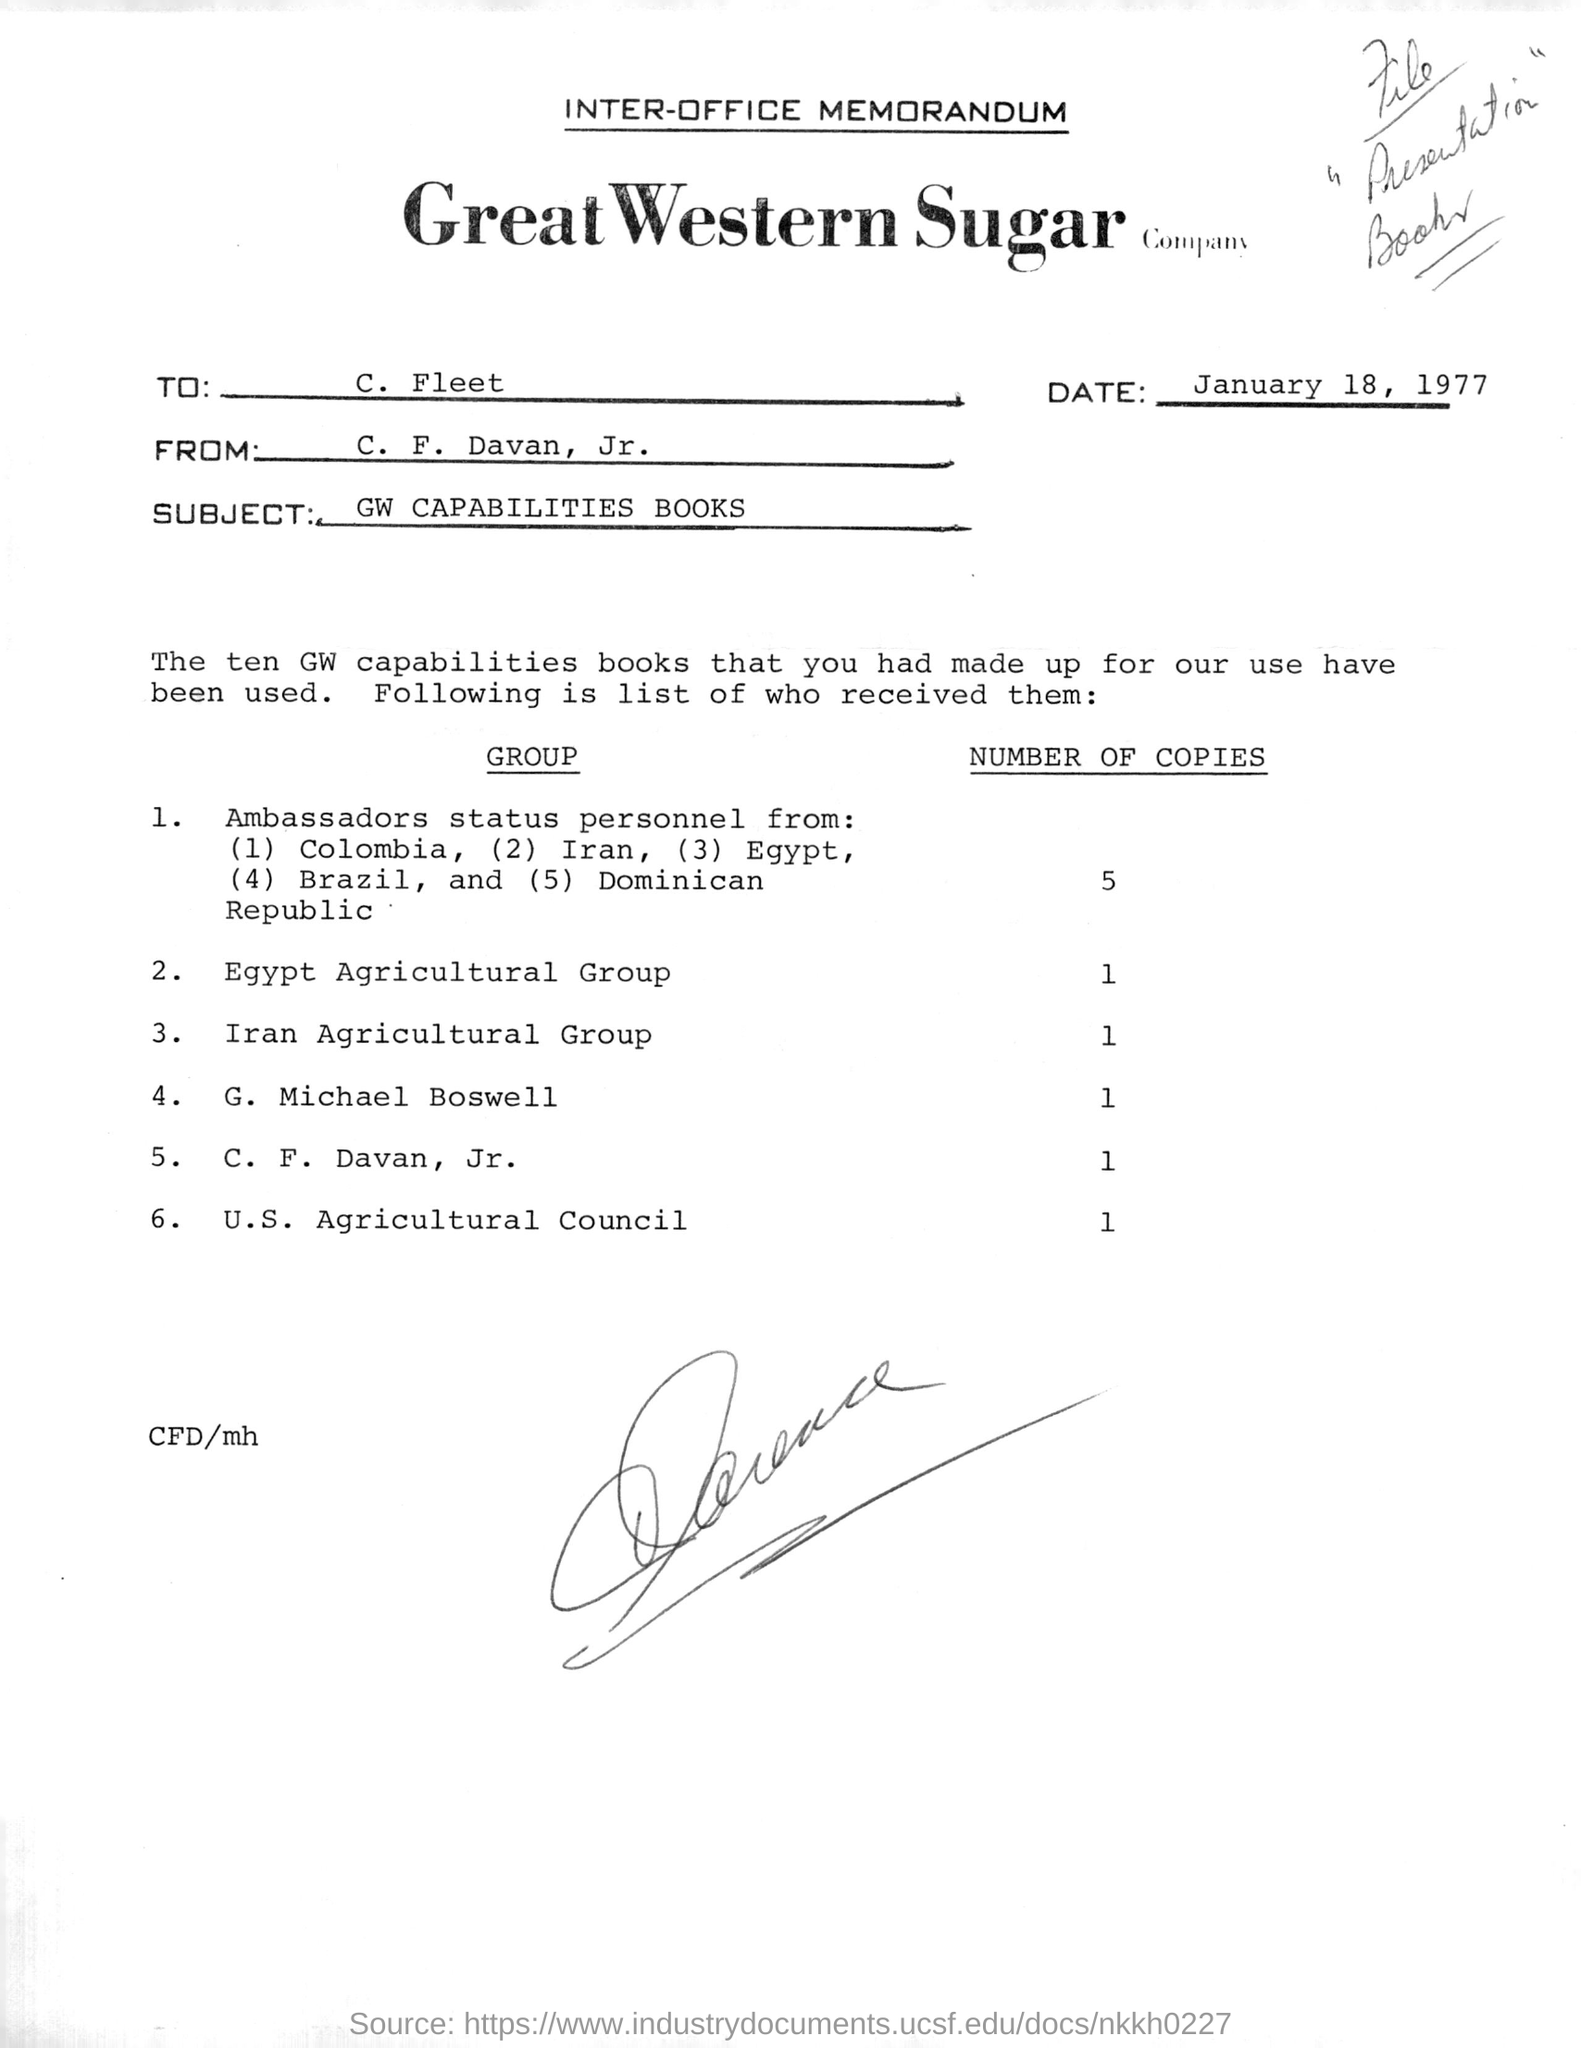Identify some key points in this picture. The memorandum states that the date is January 18, 1977. The U.S. Agricultural Council received a total of 1 book. G. Michael Boswell received one book. This memorandum is addressed to C. Fleet. The subject of the memorandum is "GW CAPABILITIES BOOKS. 